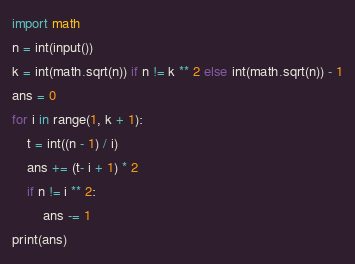<code> <loc_0><loc_0><loc_500><loc_500><_Python_>import math
n = int(input())
k = int(math.sqrt(n)) if n != k ** 2 else int(math.sqrt(n)) - 1
ans = 0
for i in range(1, k + 1):
    t = int((n - 1) / i)
    ans += (t- i + 1) * 2
    if n != i ** 2:
        ans -= 1 
print(ans)</code> 